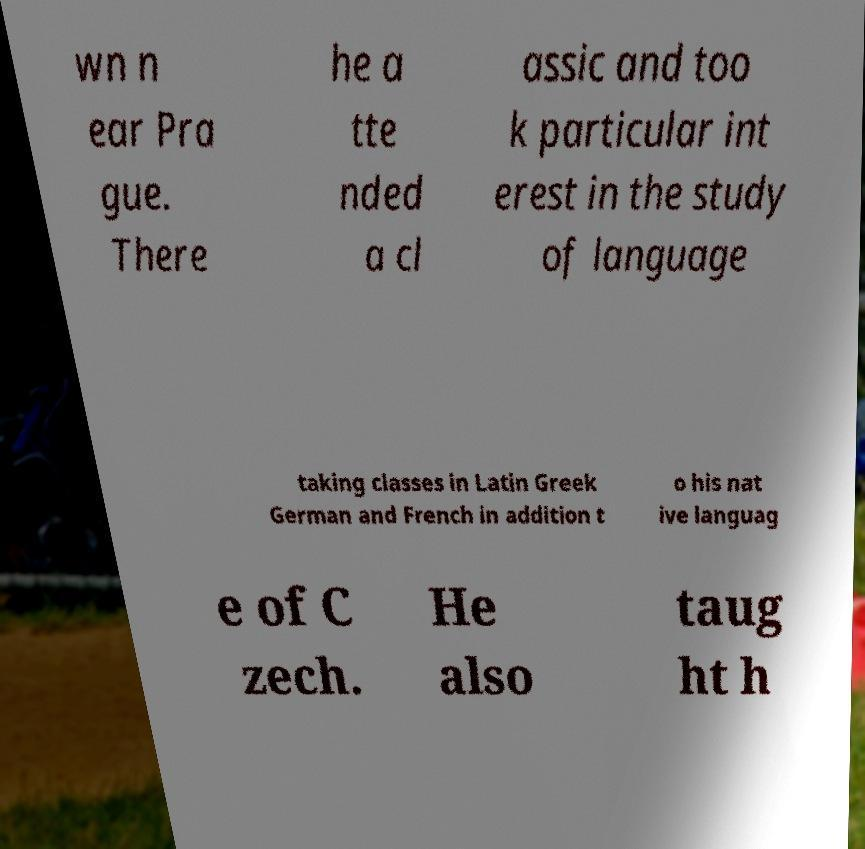Can you read and provide the text displayed in the image?This photo seems to have some interesting text. Can you extract and type it out for me? wn n ear Pra gue. There he a tte nded a cl assic and too k particular int erest in the study of language taking classes in Latin Greek German and French in addition t o his nat ive languag e of C zech. He also taug ht h 